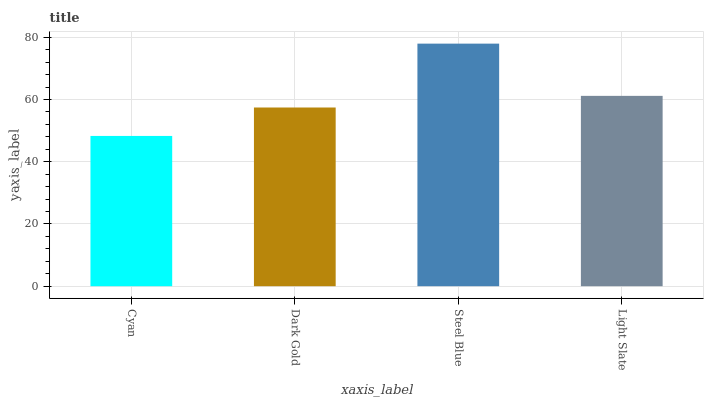Is Cyan the minimum?
Answer yes or no. Yes. Is Steel Blue the maximum?
Answer yes or no. Yes. Is Dark Gold the minimum?
Answer yes or no. No. Is Dark Gold the maximum?
Answer yes or no. No. Is Dark Gold greater than Cyan?
Answer yes or no. Yes. Is Cyan less than Dark Gold?
Answer yes or no. Yes. Is Cyan greater than Dark Gold?
Answer yes or no. No. Is Dark Gold less than Cyan?
Answer yes or no. No. Is Light Slate the high median?
Answer yes or no. Yes. Is Dark Gold the low median?
Answer yes or no. Yes. Is Cyan the high median?
Answer yes or no. No. Is Light Slate the low median?
Answer yes or no. No. 